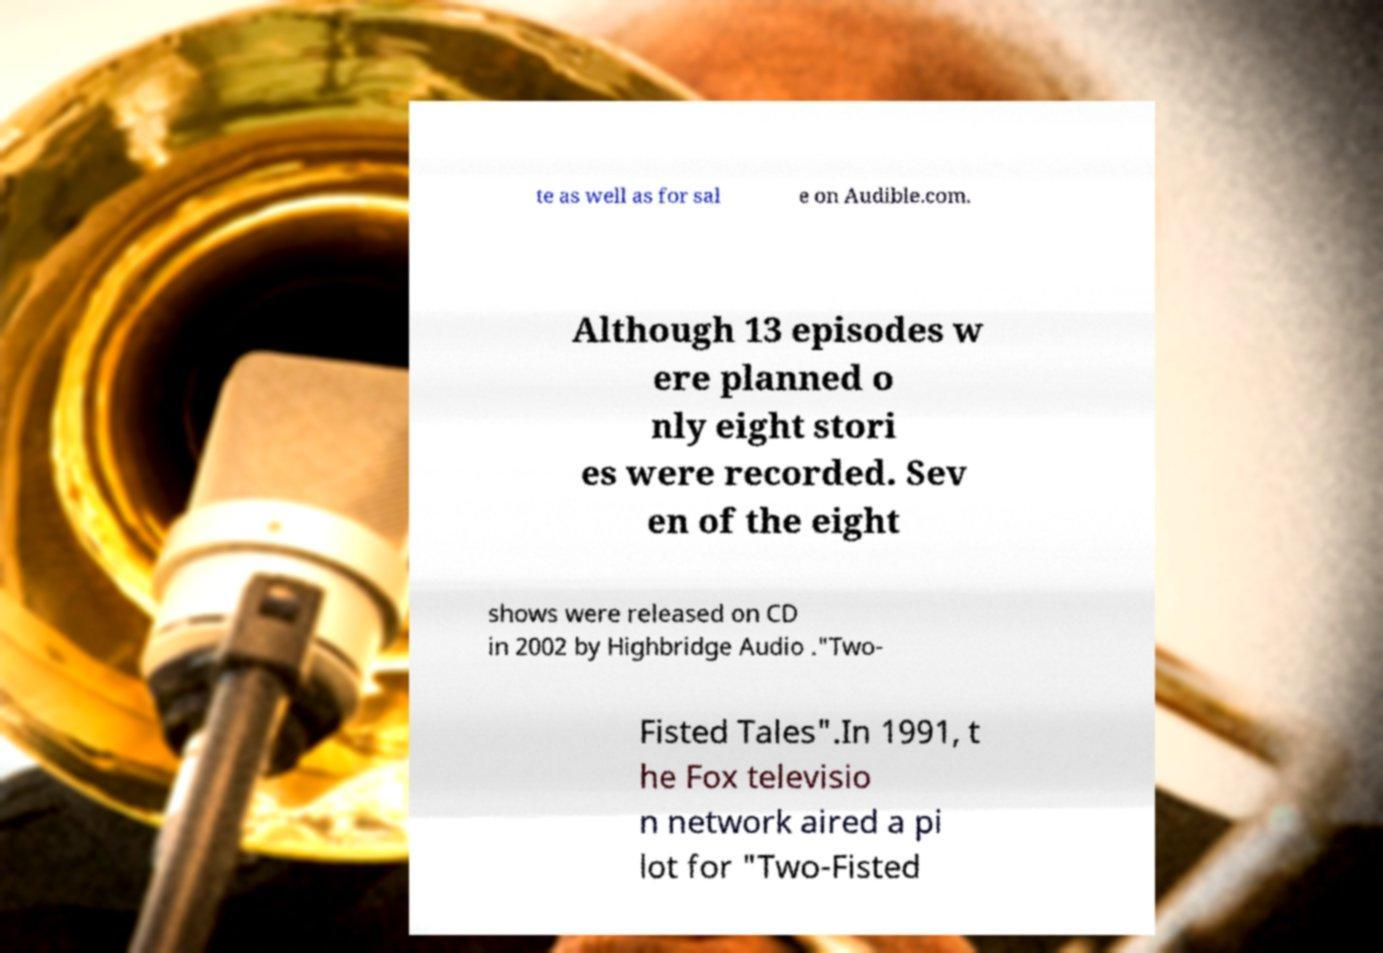Could you assist in decoding the text presented in this image and type it out clearly? te as well as for sal e on Audible.com. Although 13 episodes w ere planned o nly eight stori es were recorded. Sev en of the eight shows were released on CD in 2002 by Highbridge Audio ."Two- Fisted Tales".In 1991, t he Fox televisio n network aired a pi lot for "Two-Fisted 